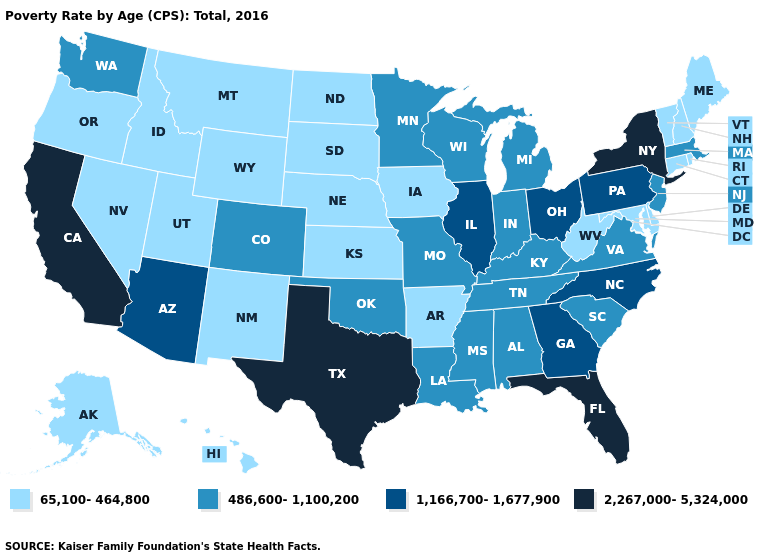Does Delaware have the lowest value in the USA?
Short answer required. Yes. Name the states that have a value in the range 1,166,700-1,677,900?
Keep it brief. Arizona, Georgia, Illinois, North Carolina, Ohio, Pennsylvania. Is the legend a continuous bar?
Write a very short answer. No. What is the value of Oregon?
Keep it brief. 65,100-464,800. Name the states that have a value in the range 1,166,700-1,677,900?
Be succinct. Arizona, Georgia, Illinois, North Carolina, Ohio, Pennsylvania. Which states have the lowest value in the USA?
Answer briefly. Alaska, Arkansas, Connecticut, Delaware, Hawaii, Idaho, Iowa, Kansas, Maine, Maryland, Montana, Nebraska, Nevada, New Hampshire, New Mexico, North Dakota, Oregon, Rhode Island, South Dakota, Utah, Vermont, West Virginia, Wyoming. Name the states that have a value in the range 486,600-1,100,200?
Short answer required. Alabama, Colorado, Indiana, Kentucky, Louisiana, Massachusetts, Michigan, Minnesota, Mississippi, Missouri, New Jersey, Oklahoma, South Carolina, Tennessee, Virginia, Washington, Wisconsin. Does the map have missing data?
Write a very short answer. No. Name the states that have a value in the range 2,267,000-5,324,000?
Quick response, please. California, Florida, New York, Texas. Name the states that have a value in the range 65,100-464,800?
Concise answer only. Alaska, Arkansas, Connecticut, Delaware, Hawaii, Idaho, Iowa, Kansas, Maine, Maryland, Montana, Nebraska, Nevada, New Hampshire, New Mexico, North Dakota, Oregon, Rhode Island, South Dakota, Utah, Vermont, West Virginia, Wyoming. Which states have the lowest value in the USA?
Short answer required. Alaska, Arkansas, Connecticut, Delaware, Hawaii, Idaho, Iowa, Kansas, Maine, Maryland, Montana, Nebraska, Nevada, New Hampshire, New Mexico, North Dakota, Oregon, Rhode Island, South Dakota, Utah, Vermont, West Virginia, Wyoming. Among the states that border Utah , which have the lowest value?
Answer briefly. Idaho, Nevada, New Mexico, Wyoming. Name the states that have a value in the range 65,100-464,800?
Be succinct. Alaska, Arkansas, Connecticut, Delaware, Hawaii, Idaho, Iowa, Kansas, Maine, Maryland, Montana, Nebraska, Nevada, New Hampshire, New Mexico, North Dakota, Oregon, Rhode Island, South Dakota, Utah, Vermont, West Virginia, Wyoming. Which states have the lowest value in the USA?
Concise answer only. Alaska, Arkansas, Connecticut, Delaware, Hawaii, Idaho, Iowa, Kansas, Maine, Maryland, Montana, Nebraska, Nevada, New Hampshire, New Mexico, North Dakota, Oregon, Rhode Island, South Dakota, Utah, Vermont, West Virginia, Wyoming. Is the legend a continuous bar?
Give a very brief answer. No. 